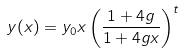<formula> <loc_0><loc_0><loc_500><loc_500>y ( x ) = y _ { 0 } x \left ( \frac { 1 + 4 g } { 1 + 4 g x } \right ) ^ { t }</formula> 